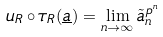Convert formula to latex. <formula><loc_0><loc_0><loc_500><loc_500>u _ { R } \circ \tau _ { R } ( \underline { a } ) = \lim _ { n \to \infty } \tilde { a } _ { n } ^ { p ^ { n } }</formula> 